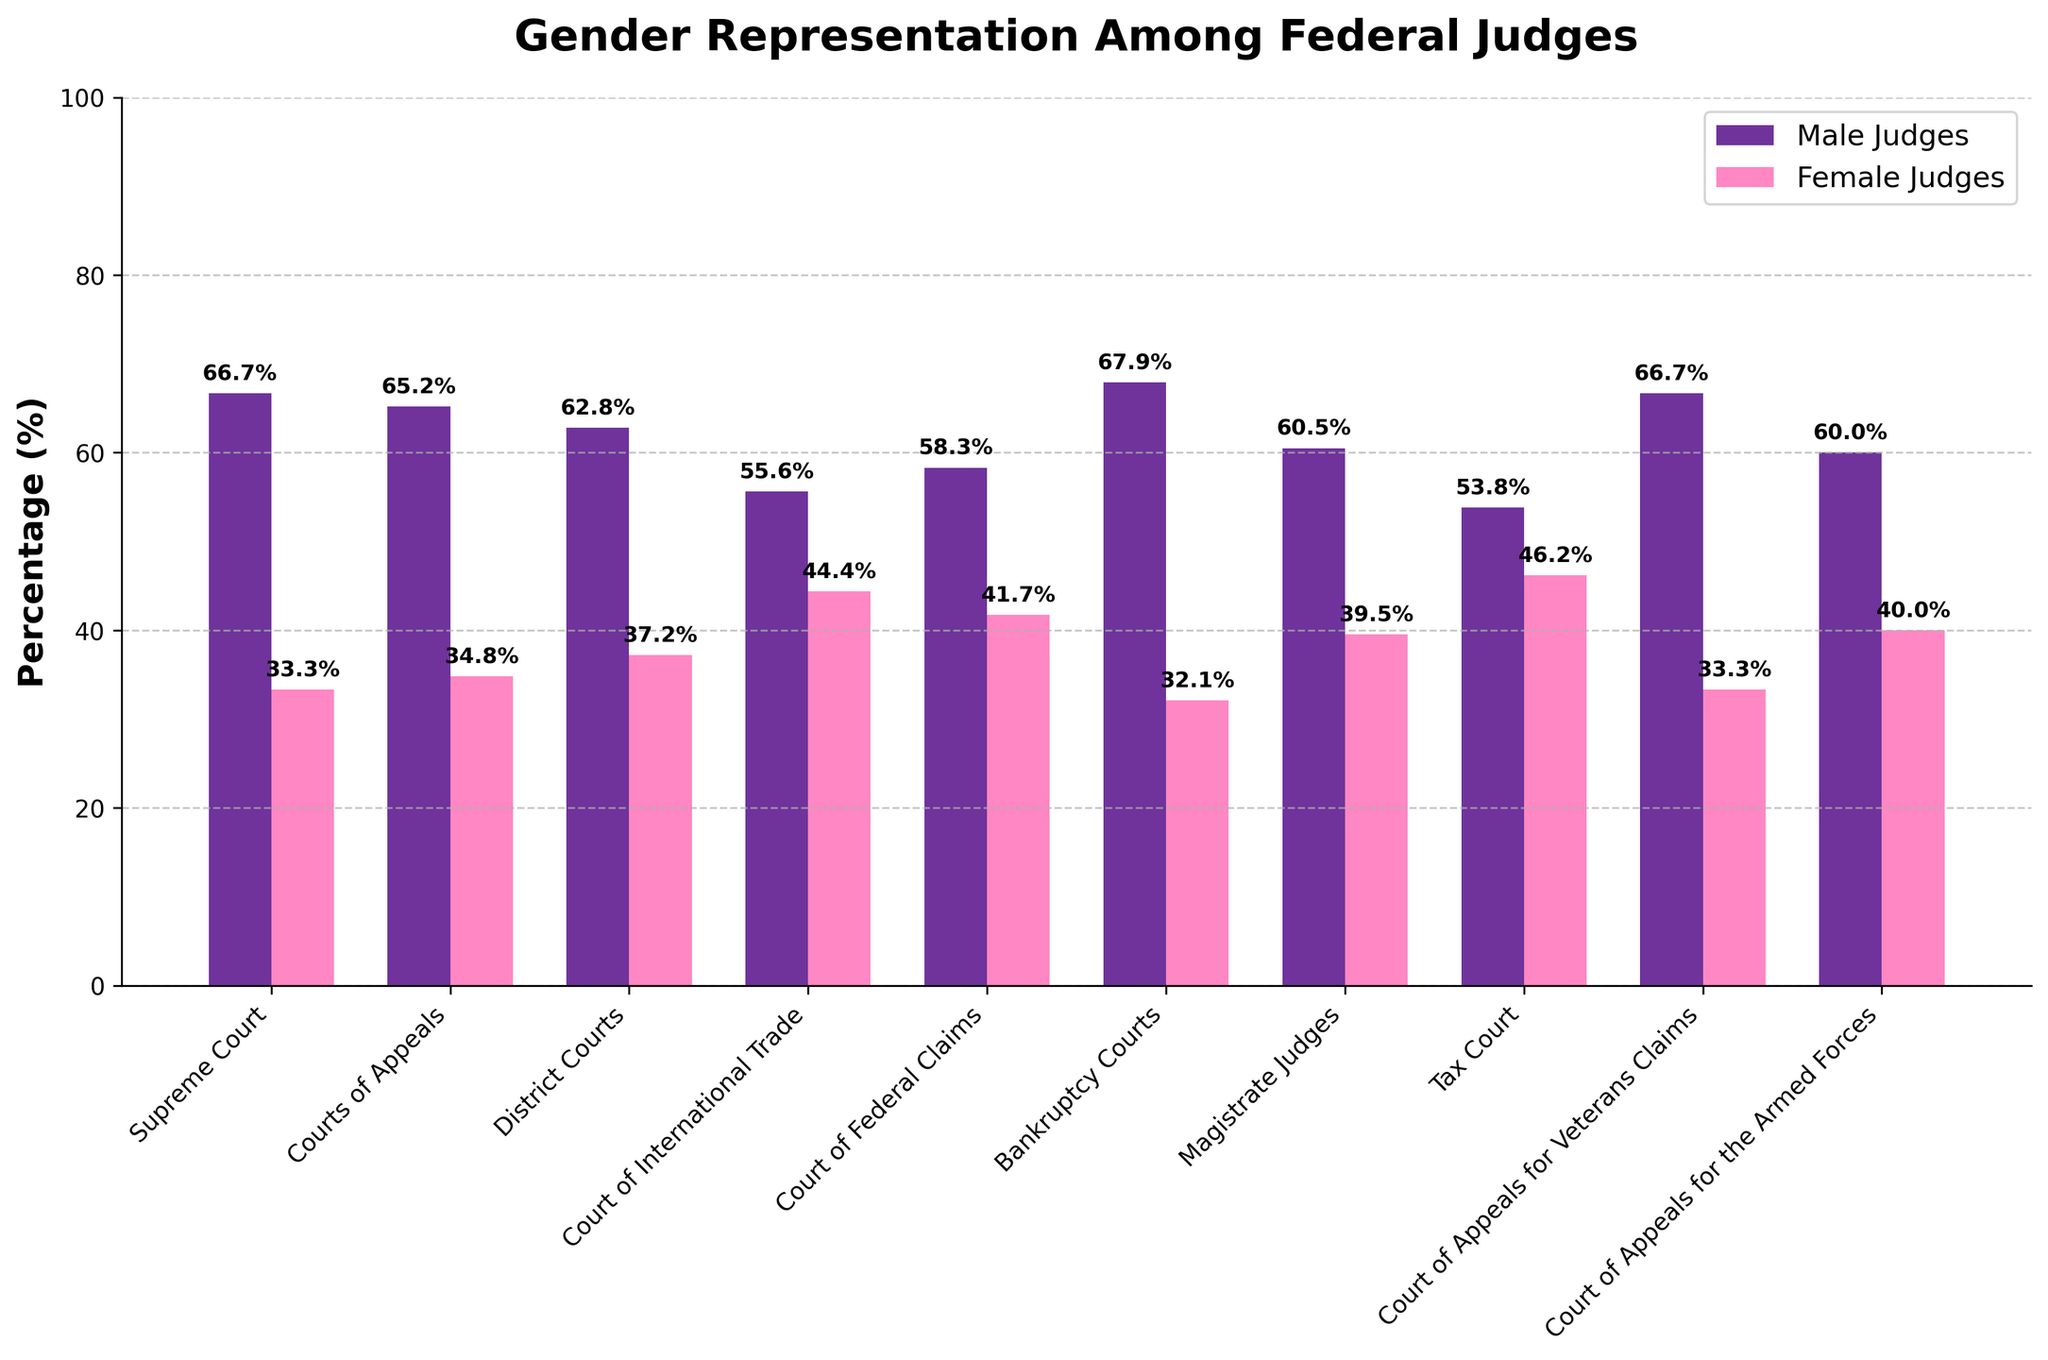Which court level has the highest percentage of female judges? By examining the heights of the pink bars, we can see that the Tax Court has the highest percentage of female judges at 46.2%.
Answer: Tax Court Which court level has the smallest gender gap among judges? The gender gap can be determined by subtracting the percentage of female judges from the percentage of male judges for each court level. The Court of International Trade has the smallest gender gap, with a difference of 11.2%.
Answer: Court of International Trade Do male judges dominate the representation in most of the court levels? By observing the chart, it's clear that in almost all court levels, the purple bars (representing male judges) are higher than the pink bars (representing female judges), indicating male dominance.
Answer: Yes Compare the gender representation in the Supreme Court and the Court of Appeals for Veterans Claims. Both the Supreme Court and the Court of Appeals for Veterans Claims have similar gender representation, with 66.7% male judges and 33.3% female judges each.
Answer: Similar What is the combined percentage of female judges in District Courts and Bankruptcy Courts? The percentage of female judges in the District Courts is 37.2%, and in Bankruptcy Courts, it's 32.1%. Adding these together, we get 37.2% + 32.1% = 69.3%.
Answer: 69.3% Which court level has the closest male-female representation ratio? By comparing the male and female percentages, the Tax Court has the closest male-female ratio with 53.8% male judges and 46.2% female judges, making it almost balanced.
Answer: Tax Court Find the difference in female judge representation between the Bankruptcy Courts and Magistrate Judges. The female judge representation in Bankruptcy Courts is 32.1%, and for Magistrate Judges, it is 39.5%. The difference is 39.5% - 32.1% = 7.4%.
Answer: 7.4% At which court level is the female representation more than 40%? By observing the heights of the pink bars, the Court of International Trade (44.4%), Court of Federal Claims (41.7%), and Tax Court (46.2%) have more than 40% female representation.
Answer: CIT, CFC, Tax Court 